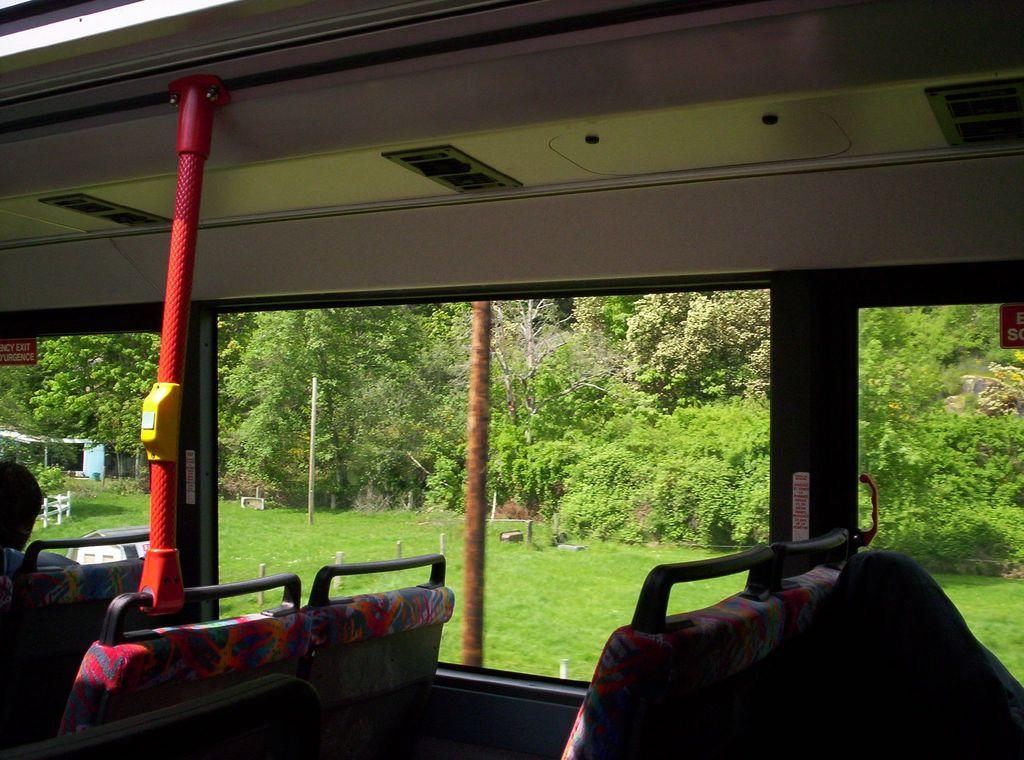What is the setting of the image? The image is inside a vehicle. What can be found inside the vehicle? There are seats and a rod in the vehicle. What type of windows are present in the vehicle? There are glass windows in the vehicle. What can be seen through the windows? Grass and trees are visible through the windows. What types of toys are being played with by the trees in the image? There are no toys present in the image, and the trees are not playing with anything. 